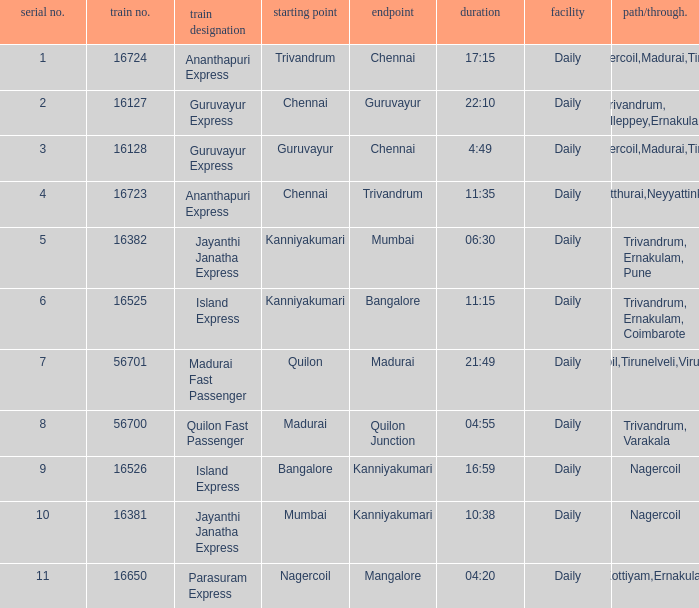What is the train number when the time is 10:38? 16381.0. 